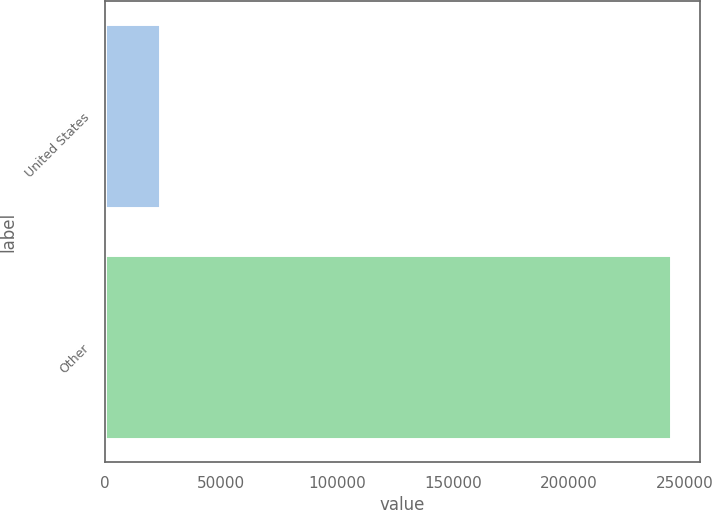<chart> <loc_0><loc_0><loc_500><loc_500><bar_chart><fcel>United States<fcel>Other<nl><fcel>23875<fcel>243985<nl></chart> 